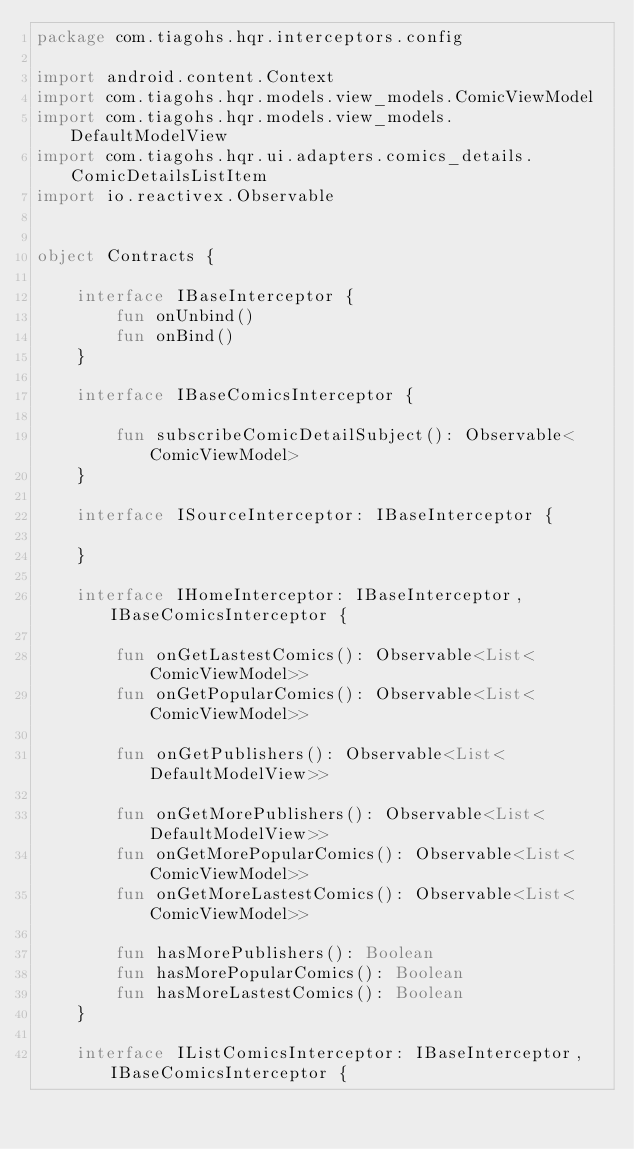Convert code to text. <code><loc_0><loc_0><loc_500><loc_500><_Kotlin_>package com.tiagohs.hqr.interceptors.config

import android.content.Context
import com.tiagohs.hqr.models.view_models.ComicViewModel
import com.tiagohs.hqr.models.view_models.DefaultModelView
import com.tiagohs.hqr.ui.adapters.comics_details.ComicDetailsListItem
import io.reactivex.Observable


object Contracts {

    interface IBaseInterceptor {
        fun onUnbind()
        fun onBind()
    }

    interface IBaseComicsInterceptor {

        fun subscribeComicDetailSubject(): Observable<ComicViewModel>
    }

    interface ISourceInterceptor: IBaseInterceptor {

    }

    interface IHomeInterceptor: IBaseInterceptor, IBaseComicsInterceptor {

        fun onGetLastestComics(): Observable<List<ComicViewModel>>
        fun onGetPopularComics(): Observable<List<ComicViewModel>>

        fun onGetPublishers(): Observable<List<DefaultModelView>>

        fun onGetMorePublishers(): Observable<List<DefaultModelView>>
        fun onGetMorePopularComics(): Observable<List<ComicViewModel>>
        fun onGetMoreLastestComics(): Observable<List<ComicViewModel>>

        fun hasMorePublishers(): Boolean
        fun hasMorePopularComics(): Boolean
        fun hasMoreLastestComics(): Boolean
    }

    interface IListComicsInterceptor: IBaseInterceptor, IBaseComicsInterceptor {
</code> 